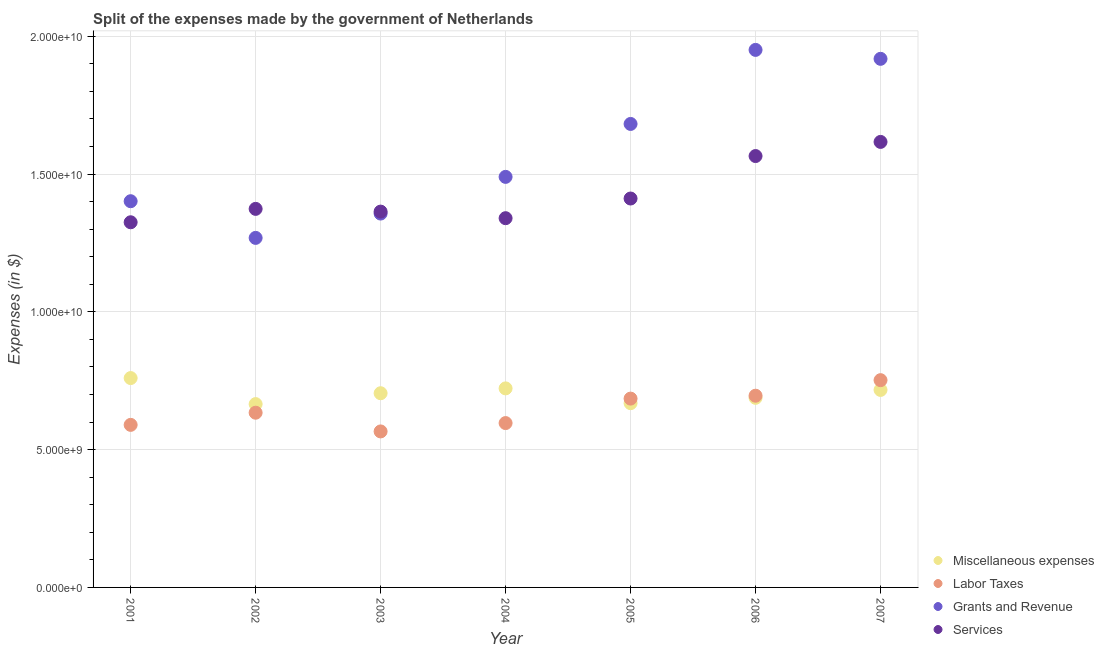How many different coloured dotlines are there?
Ensure brevity in your answer.  4. Is the number of dotlines equal to the number of legend labels?
Make the answer very short. Yes. What is the amount spent on labor taxes in 2002?
Your response must be concise. 6.34e+09. Across all years, what is the maximum amount spent on grants and revenue?
Offer a very short reply. 1.95e+1. Across all years, what is the minimum amount spent on services?
Give a very brief answer. 1.33e+1. In which year was the amount spent on grants and revenue maximum?
Make the answer very short. 2006. What is the total amount spent on labor taxes in the graph?
Ensure brevity in your answer.  4.52e+1. What is the difference between the amount spent on grants and revenue in 2002 and that in 2005?
Make the answer very short. -4.14e+09. What is the difference between the amount spent on miscellaneous expenses in 2003 and the amount spent on labor taxes in 2004?
Ensure brevity in your answer.  1.08e+09. What is the average amount spent on services per year?
Your response must be concise. 1.43e+1. In the year 2002, what is the difference between the amount spent on miscellaneous expenses and amount spent on services?
Keep it short and to the point. -7.08e+09. In how many years, is the amount spent on services greater than 14000000000 $?
Make the answer very short. 3. What is the ratio of the amount spent on grants and revenue in 2002 to that in 2004?
Offer a terse response. 0.85. Is the amount spent on miscellaneous expenses in 2004 less than that in 2007?
Make the answer very short. No. What is the difference between the highest and the second highest amount spent on miscellaneous expenses?
Make the answer very short. 3.74e+08. What is the difference between the highest and the lowest amount spent on miscellaneous expenses?
Your answer should be very brief. 9.44e+08. In how many years, is the amount spent on grants and revenue greater than the average amount spent on grants and revenue taken over all years?
Keep it short and to the point. 3. Is it the case that in every year, the sum of the amount spent on grants and revenue and amount spent on miscellaneous expenses is greater than the sum of amount spent on services and amount spent on labor taxes?
Give a very brief answer. No. Does the amount spent on miscellaneous expenses monotonically increase over the years?
Provide a short and direct response. No. Is the amount spent on grants and revenue strictly greater than the amount spent on services over the years?
Offer a very short reply. No. How many dotlines are there?
Offer a terse response. 4. Does the graph contain grids?
Provide a short and direct response. Yes. Where does the legend appear in the graph?
Your answer should be compact. Bottom right. How many legend labels are there?
Make the answer very short. 4. What is the title of the graph?
Your answer should be very brief. Split of the expenses made by the government of Netherlands. Does "Source data assessment" appear as one of the legend labels in the graph?
Your response must be concise. No. What is the label or title of the X-axis?
Ensure brevity in your answer.  Year. What is the label or title of the Y-axis?
Give a very brief answer. Expenses (in $). What is the Expenses (in $) of Miscellaneous expenses in 2001?
Your answer should be compact. 7.60e+09. What is the Expenses (in $) of Labor Taxes in 2001?
Offer a terse response. 5.90e+09. What is the Expenses (in $) in Grants and Revenue in 2001?
Keep it short and to the point. 1.40e+1. What is the Expenses (in $) in Services in 2001?
Ensure brevity in your answer.  1.33e+1. What is the Expenses (in $) in Miscellaneous expenses in 2002?
Your answer should be very brief. 6.65e+09. What is the Expenses (in $) of Labor Taxes in 2002?
Ensure brevity in your answer.  6.34e+09. What is the Expenses (in $) in Grants and Revenue in 2002?
Offer a very short reply. 1.27e+1. What is the Expenses (in $) in Services in 2002?
Offer a very short reply. 1.37e+1. What is the Expenses (in $) in Miscellaneous expenses in 2003?
Your response must be concise. 7.05e+09. What is the Expenses (in $) in Labor Taxes in 2003?
Keep it short and to the point. 5.66e+09. What is the Expenses (in $) of Grants and Revenue in 2003?
Your answer should be very brief. 1.36e+1. What is the Expenses (in $) of Services in 2003?
Ensure brevity in your answer.  1.36e+1. What is the Expenses (in $) in Miscellaneous expenses in 2004?
Your response must be concise. 7.22e+09. What is the Expenses (in $) of Labor Taxes in 2004?
Ensure brevity in your answer.  5.96e+09. What is the Expenses (in $) of Grants and Revenue in 2004?
Offer a very short reply. 1.49e+1. What is the Expenses (in $) of Services in 2004?
Your answer should be compact. 1.34e+1. What is the Expenses (in $) in Miscellaneous expenses in 2005?
Your response must be concise. 6.69e+09. What is the Expenses (in $) in Labor Taxes in 2005?
Your response must be concise. 6.85e+09. What is the Expenses (in $) of Grants and Revenue in 2005?
Your answer should be very brief. 1.68e+1. What is the Expenses (in $) in Services in 2005?
Make the answer very short. 1.41e+1. What is the Expenses (in $) in Miscellaneous expenses in 2006?
Your response must be concise. 6.88e+09. What is the Expenses (in $) in Labor Taxes in 2006?
Offer a terse response. 6.96e+09. What is the Expenses (in $) in Grants and Revenue in 2006?
Provide a succinct answer. 1.95e+1. What is the Expenses (in $) in Services in 2006?
Your answer should be very brief. 1.57e+1. What is the Expenses (in $) of Miscellaneous expenses in 2007?
Your answer should be compact. 7.17e+09. What is the Expenses (in $) of Labor Taxes in 2007?
Make the answer very short. 7.52e+09. What is the Expenses (in $) of Grants and Revenue in 2007?
Keep it short and to the point. 1.92e+1. What is the Expenses (in $) of Services in 2007?
Your answer should be compact. 1.62e+1. Across all years, what is the maximum Expenses (in $) in Miscellaneous expenses?
Provide a short and direct response. 7.60e+09. Across all years, what is the maximum Expenses (in $) in Labor Taxes?
Ensure brevity in your answer.  7.52e+09. Across all years, what is the maximum Expenses (in $) of Grants and Revenue?
Offer a terse response. 1.95e+1. Across all years, what is the maximum Expenses (in $) of Services?
Give a very brief answer. 1.62e+1. Across all years, what is the minimum Expenses (in $) of Miscellaneous expenses?
Offer a very short reply. 6.65e+09. Across all years, what is the minimum Expenses (in $) in Labor Taxes?
Offer a terse response. 5.66e+09. Across all years, what is the minimum Expenses (in $) in Grants and Revenue?
Your response must be concise. 1.27e+1. Across all years, what is the minimum Expenses (in $) of Services?
Provide a short and direct response. 1.33e+1. What is the total Expenses (in $) of Miscellaneous expenses in the graph?
Provide a short and direct response. 4.93e+1. What is the total Expenses (in $) of Labor Taxes in the graph?
Offer a very short reply. 4.52e+1. What is the total Expenses (in $) of Grants and Revenue in the graph?
Make the answer very short. 1.11e+11. What is the total Expenses (in $) of Services in the graph?
Make the answer very short. 1.00e+11. What is the difference between the Expenses (in $) of Miscellaneous expenses in 2001 and that in 2002?
Your answer should be very brief. 9.44e+08. What is the difference between the Expenses (in $) in Labor Taxes in 2001 and that in 2002?
Your answer should be compact. -4.41e+08. What is the difference between the Expenses (in $) in Grants and Revenue in 2001 and that in 2002?
Your response must be concise. 1.33e+09. What is the difference between the Expenses (in $) in Services in 2001 and that in 2002?
Your answer should be very brief. -4.86e+08. What is the difference between the Expenses (in $) of Miscellaneous expenses in 2001 and that in 2003?
Ensure brevity in your answer.  5.50e+08. What is the difference between the Expenses (in $) in Labor Taxes in 2001 and that in 2003?
Offer a very short reply. 2.38e+08. What is the difference between the Expenses (in $) of Grants and Revenue in 2001 and that in 2003?
Offer a very short reply. 4.48e+08. What is the difference between the Expenses (in $) in Services in 2001 and that in 2003?
Make the answer very short. -3.87e+08. What is the difference between the Expenses (in $) of Miscellaneous expenses in 2001 and that in 2004?
Make the answer very short. 3.74e+08. What is the difference between the Expenses (in $) of Labor Taxes in 2001 and that in 2004?
Your answer should be very brief. -6.50e+07. What is the difference between the Expenses (in $) of Grants and Revenue in 2001 and that in 2004?
Your answer should be compact. -8.83e+08. What is the difference between the Expenses (in $) in Services in 2001 and that in 2004?
Offer a very short reply. -1.48e+08. What is the difference between the Expenses (in $) in Miscellaneous expenses in 2001 and that in 2005?
Provide a succinct answer. 9.11e+08. What is the difference between the Expenses (in $) of Labor Taxes in 2001 and that in 2005?
Provide a succinct answer. -9.53e+08. What is the difference between the Expenses (in $) in Grants and Revenue in 2001 and that in 2005?
Your response must be concise. -2.80e+09. What is the difference between the Expenses (in $) in Services in 2001 and that in 2005?
Offer a very short reply. -8.62e+08. What is the difference between the Expenses (in $) of Miscellaneous expenses in 2001 and that in 2006?
Make the answer very short. 7.17e+08. What is the difference between the Expenses (in $) in Labor Taxes in 2001 and that in 2006?
Your answer should be very brief. -1.06e+09. What is the difference between the Expenses (in $) of Grants and Revenue in 2001 and that in 2006?
Make the answer very short. -5.49e+09. What is the difference between the Expenses (in $) in Services in 2001 and that in 2006?
Offer a terse response. -2.40e+09. What is the difference between the Expenses (in $) in Miscellaneous expenses in 2001 and that in 2007?
Provide a short and direct response. 4.30e+08. What is the difference between the Expenses (in $) in Labor Taxes in 2001 and that in 2007?
Provide a short and direct response. -1.62e+09. What is the difference between the Expenses (in $) in Grants and Revenue in 2001 and that in 2007?
Your answer should be very brief. -5.17e+09. What is the difference between the Expenses (in $) in Services in 2001 and that in 2007?
Provide a short and direct response. -2.92e+09. What is the difference between the Expenses (in $) of Miscellaneous expenses in 2002 and that in 2003?
Provide a short and direct response. -3.94e+08. What is the difference between the Expenses (in $) in Labor Taxes in 2002 and that in 2003?
Your answer should be very brief. 6.79e+08. What is the difference between the Expenses (in $) in Grants and Revenue in 2002 and that in 2003?
Your answer should be very brief. -8.83e+08. What is the difference between the Expenses (in $) in Services in 2002 and that in 2003?
Offer a terse response. 9.90e+07. What is the difference between the Expenses (in $) of Miscellaneous expenses in 2002 and that in 2004?
Ensure brevity in your answer.  -5.70e+08. What is the difference between the Expenses (in $) of Labor Taxes in 2002 and that in 2004?
Provide a succinct answer. 3.76e+08. What is the difference between the Expenses (in $) in Grants and Revenue in 2002 and that in 2004?
Provide a short and direct response. -2.21e+09. What is the difference between the Expenses (in $) of Services in 2002 and that in 2004?
Keep it short and to the point. 3.38e+08. What is the difference between the Expenses (in $) of Miscellaneous expenses in 2002 and that in 2005?
Provide a short and direct response. -3.30e+07. What is the difference between the Expenses (in $) in Labor Taxes in 2002 and that in 2005?
Make the answer very short. -5.12e+08. What is the difference between the Expenses (in $) of Grants and Revenue in 2002 and that in 2005?
Provide a short and direct response. -4.14e+09. What is the difference between the Expenses (in $) in Services in 2002 and that in 2005?
Ensure brevity in your answer.  -3.76e+08. What is the difference between the Expenses (in $) in Miscellaneous expenses in 2002 and that in 2006?
Make the answer very short. -2.27e+08. What is the difference between the Expenses (in $) in Labor Taxes in 2002 and that in 2006?
Your answer should be very brief. -6.17e+08. What is the difference between the Expenses (in $) in Grants and Revenue in 2002 and that in 2006?
Provide a succinct answer. -6.82e+09. What is the difference between the Expenses (in $) of Services in 2002 and that in 2006?
Make the answer very short. -1.92e+09. What is the difference between the Expenses (in $) in Miscellaneous expenses in 2002 and that in 2007?
Give a very brief answer. -5.14e+08. What is the difference between the Expenses (in $) in Labor Taxes in 2002 and that in 2007?
Offer a very short reply. -1.18e+09. What is the difference between the Expenses (in $) in Grants and Revenue in 2002 and that in 2007?
Offer a very short reply. -6.50e+09. What is the difference between the Expenses (in $) in Services in 2002 and that in 2007?
Give a very brief answer. -2.43e+09. What is the difference between the Expenses (in $) in Miscellaneous expenses in 2003 and that in 2004?
Your answer should be very brief. -1.76e+08. What is the difference between the Expenses (in $) in Labor Taxes in 2003 and that in 2004?
Provide a succinct answer. -3.03e+08. What is the difference between the Expenses (in $) of Grants and Revenue in 2003 and that in 2004?
Keep it short and to the point. -1.33e+09. What is the difference between the Expenses (in $) in Services in 2003 and that in 2004?
Ensure brevity in your answer.  2.39e+08. What is the difference between the Expenses (in $) of Miscellaneous expenses in 2003 and that in 2005?
Offer a very short reply. 3.61e+08. What is the difference between the Expenses (in $) of Labor Taxes in 2003 and that in 2005?
Your response must be concise. -1.19e+09. What is the difference between the Expenses (in $) in Grants and Revenue in 2003 and that in 2005?
Offer a very short reply. -3.25e+09. What is the difference between the Expenses (in $) of Services in 2003 and that in 2005?
Keep it short and to the point. -4.75e+08. What is the difference between the Expenses (in $) of Miscellaneous expenses in 2003 and that in 2006?
Provide a short and direct response. 1.67e+08. What is the difference between the Expenses (in $) of Labor Taxes in 2003 and that in 2006?
Give a very brief answer. -1.30e+09. What is the difference between the Expenses (in $) in Grants and Revenue in 2003 and that in 2006?
Your response must be concise. -5.94e+09. What is the difference between the Expenses (in $) in Services in 2003 and that in 2006?
Your response must be concise. -2.02e+09. What is the difference between the Expenses (in $) in Miscellaneous expenses in 2003 and that in 2007?
Offer a terse response. -1.20e+08. What is the difference between the Expenses (in $) of Labor Taxes in 2003 and that in 2007?
Your response must be concise. -1.86e+09. What is the difference between the Expenses (in $) in Grants and Revenue in 2003 and that in 2007?
Keep it short and to the point. -5.62e+09. What is the difference between the Expenses (in $) in Services in 2003 and that in 2007?
Provide a short and direct response. -2.53e+09. What is the difference between the Expenses (in $) of Miscellaneous expenses in 2004 and that in 2005?
Offer a very short reply. 5.37e+08. What is the difference between the Expenses (in $) of Labor Taxes in 2004 and that in 2005?
Make the answer very short. -8.88e+08. What is the difference between the Expenses (in $) in Grants and Revenue in 2004 and that in 2005?
Ensure brevity in your answer.  -1.92e+09. What is the difference between the Expenses (in $) of Services in 2004 and that in 2005?
Your answer should be very brief. -7.14e+08. What is the difference between the Expenses (in $) of Miscellaneous expenses in 2004 and that in 2006?
Offer a terse response. 3.43e+08. What is the difference between the Expenses (in $) of Labor Taxes in 2004 and that in 2006?
Give a very brief answer. -9.93e+08. What is the difference between the Expenses (in $) of Grants and Revenue in 2004 and that in 2006?
Provide a short and direct response. -4.61e+09. What is the difference between the Expenses (in $) of Services in 2004 and that in 2006?
Offer a very short reply. -2.26e+09. What is the difference between the Expenses (in $) in Miscellaneous expenses in 2004 and that in 2007?
Make the answer very short. 5.60e+07. What is the difference between the Expenses (in $) of Labor Taxes in 2004 and that in 2007?
Your answer should be very brief. -1.56e+09. What is the difference between the Expenses (in $) of Grants and Revenue in 2004 and that in 2007?
Offer a very short reply. -4.28e+09. What is the difference between the Expenses (in $) in Services in 2004 and that in 2007?
Ensure brevity in your answer.  -2.77e+09. What is the difference between the Expenses (in $) of Miscellaneous expenses in 2005 and that in 2006?
Provide a short and direct response. -1.94e+08. What is the difference between the Expenses (in $) of Labor Taxes in 2005 and that in 2006?
Provide a succinct answer. -1.05e+08. What is the difference between the Expenses (in $) in Grants and Revenue in 2005 and that in 2006?
Your answer should be very brief. -2.69e+09. What is the difference between the Expenses (in $) in Services in 2005 and that in 2006?
Keep it short and to the point. -1.54e+09. What is the difference between the Expenses (in $) in Miscellaneous expenses in 2005 and that in 2007?
Keep it short and to the point. -4.81e+08. What is the difference between the Expenses (in $) in Labor Taxes in 2005 and that in 2007?
Make the answer very short. -6.69e+08. What is the difference between the Expenses (in $) of Grants and Revenue in 2005 and that in 2007?
Provide a short and direct response. -2.36e+09. What is the difference between the Expenses (in $) of Services in 2005 and that in 2007?
Ensure brevity in your answer.  -2.05e+09. What is the difference between the Expenses (in $) of Miscellaneous expenses in 2006 and that in 2007?
Ensure brevity in your answer.  -2.87e+08. What is the difference between the Expenses (in $) in Labor Taxes in 2006 and that in 2007?
Ensure brevity in your answer.  -5.64e+08. What is the difference between the Expenses (in $) of Grants and Revenue in 2006 and that in 2007?
Provide a short and direct response. 3.24e+08. What is the difference between the Expenses (in $) in Services in 2006 and that in 2007?
Make the answer very short. -5.13e+08. What is the difference between the Expenses (in $) in Miscellaneous expenses in 2001 and the Expenses (in $) in Labor Taxes in 2002?
Make the answer very short. 1.26e+09. What is the difference between the Expenses (in $) in Miscellaneous expenses in 2001 and the Expenses (in $) in Grants and Revenue in 2002?
Your answer should be compact. -5.09e+09. What is the difference between the Expenses (in $) in Miscellaneous expenses in 2001 and the Expenses (in $) in Services in 2002?
Give a very brief answer. -6.14e+09. What is the difference between the Expenses (in $) in Labor Taxes in 2001 and the Expenses (in $) in Grants and Revenue in 2002?
Your response must be concise. -6.78e+09. What is the difference between the Expenses (in $) of Labor Taxes in 2001 and the Expenses (in $) of Services in 2002?
Offer a very short reply. -7.84e+09. What is the difference between the Expenses (in $) in Grants and Revenue in 2001 and the Expenses (in $) in Services in 2002?
Provide a short and direct response. 2.78e+08. What is the difference between the Expenses (in $) in Miscellaneous expenses in 2001 and the Expenses (in $) in Labor Taxes in 2003?
Provide a short and direct response. 1.94e+09. What is the difference between the Expenses (in $) of Miscellaneous expenses in 2001 and the Expenses (in $) of Grants and Revenue in 2003?
Provide a short and direct response. -5.97e+09. What is the difference between the Expenses (in $) in Miscellaneous expenses in 2001 and the Expenses (in $) in Services in 2003?
Offer a terse response. -6.04e+09. What is the difference between the Expenses (in $) in Labor Taxes in 2001 and the Expenses (in $) in Grants and Revenue in 2003?
Your answer should be compact. -7.67e+09. What is the difference between the Expenses (in $) of Labor Taxes in 2001 and the Expenses (in $) of Services in 2003?
Ensure brevity in your answer.  -7.74e+09. What is the difference between the Expenses (in $) of Grants and Revenue in 2001 and the Expenses (in $) of Services in 2003?
Your answer should be very brief. 3.77e+08. What is the difference between the Expenses (in $) in Miscellaneous expenses in 2001 and the Expenses (in $) in Labor Taxes in 2004?
Offer a terse response. 1.63e+09. What is the difference between the Expenses (in $) in Miscellaneous expenses in 2001 and the Expenses (in $) in Grants and Revenue in 2004?
Your answer should be compact. -7.30e+09. What is the difference between the Expenses (in $) in Miscellaneous expenses in 2001 and the Expenses (in $) in Services in 2004?
Keep it short and to the point. -5.80e+09. What is the difference between the Expenses (in $) in Labor Taxes in 2001 and the Expenses (in $) in Grants and Revenue in 2004?
Offer a very short reply. -9.00e+09. What is the difference between the Expenses (in $) in Labor Taxes in 2001 and the Expenses (in $) in Services in 2004?
Your answer should be compact. -7.50e+09. What is the difference between the Expenses (in $) of Grants and Revenue in 2001 and the Expenses (in $) of Services in 2004?
Provide a short and direct response. 6.16e+08. What is the difference between the Expenses (in $) in Miscellaneous expenses in 2001 and the Expenses (in $) in Labor Taxes in 2005?
Offer a terse response. 7.45e+08. What is the difference between the Expenses (in $) in Miscellaneous expenses in 2001 and the Expenses (in $) in Grants and Revenue in 2005?
Ensure brevity in your answer.  -9.22e+09. What is the difference between the Expenses (in $) in Miscellaneous expenses in 2001 and the Expenses (in $) in Services in 2005?
Make the answer very short. -6.52e+09. What is the difference between the Expenses (in $) in Labor Taxes in 2001 and the Expenses (in $) in Grants and Revenue in 2005?
Your answer should be compact. -1.09e+1. What is the difference between the Expenses (in $) of Labor Taxes in 2001 and the Expenses (in $) of Services in 2005?
Give a very brief answer. -8.21e+09. What is the difference between the Expenses (in $) in Grants and Revenue in 2001 and the Expenses (in $) in Services in 2005?
Offer a very short reply. -9.80e+07. What is the difference between the Expenses (in $) in Miscellaneous expenses in 2001 and the Expenses (in $) in Labor Taxes in 2006?
Your answer should be compact. 6.40e+08. What is the difference between the Expenses (in $) of Miscellaneous expenses in 2001 and the Expenses (in $) of Grants and Revenue in 2006?
Ensure brevity in your answer.  -1.19e+1. What is the difference between the Expenses (in $) of Miscellaneous expenses in 2001 and the Expenses (in $) of Services in 2006?
Give a very brief answer. -8.06e+09. What is the difference between the Expenses (in $) of Labor Taxes in 2001 and the Expenses (in $) of Grants and Revenue in 2006?
Give a very brief answer. -1.36e+1. What is the difference between the Expenses (in $) of Labor Taxes in 2001 and the Expenses (in $) of Services in 2006?
Give a very brief answer. -9.76e+09. What is the difference between the Expenses (in $) in Grants and Revenue in 2001 and the Expenses (in $) in Services in 2006?
Keep it short and to the point. -1.64e+09. What is the difference between the Expenses (in $) in Miscellaneous expenses in 2001 and the Expenses (in $) in Labor Taxes in 2007?
Offer a terse response. 7.60e+07. What is the difference between the Expenses (in $) in Miscellaneous expenses in 2001 and the Expenses (in $) in Grants and Revenue in 2007?
Provide a succinct answer. -1.16e+1. What is the difference between the Expenses (in $) in Miscellaneous expenses in 2001 and the Expenses (in $) in Services in 2007?
Ensure brevity in your answer.  -8.57e+09. What is the difference between the Expenses (in $) in Labor Taxes in 2001 and the Expenses (in $) in Grants and Revenue in 2007?
Your response must be concise. -1.33e+1. What is the difference between the Expenses (in $) in Labor Taxes in 2001 and the Expenses (in $) in Services in 2007?
Your response must be concise. -1.03e+1. What is the difference between the Expenses (in $) of Grants and Revenue in 2001 and the Expenses (in $) of Services in 2007?
Make the answer very short. -2.15e+09. What is the difference between the Expenses (in $) in Miscellaneous expenses in 2002 and the Expenses (in $) in Labor Taxes in 2003?
Offer a very short reply. 9.92e+08. What is the difference between the Expenses (in $) of Miscellaneous expenses in 2002 and the Expenses (in $) of Grants and Revenue in 2003?
Offer a very short reply. -6.91e+09. What is the difference between the Expenses (in $) of Miscellaneous expenses in 2002 and the Expenses (in $) of Services in 2003?
Provide a short and direct response. -6.98e+09. What is the difference between the Expenses (in $) in Labor Taxes in 2002 and the Expenses (in $) in Grants and Revenue in 2003?
Provide a short and direct response. -7.23e+09. What is the difference between the Expenses (in $) in Labor Taxes in 2002 and the Expenses (in $) in Services in 2003?
Offer a terse response. -7.30e+09. What is the difference between the Expenses (in $) of Grants and Revenue in 2002 and the Expenses (in $) of Services in 2003?
Offer a terse response. -9.54e+08. What is the difference between the Expenses (in $) of Miscellaneous expenses in 2002 and the Expenses (in $) of Labor Taxes in 2004?
Your answer should be compact. 6.89e+08. What is the difference between the Expenses (in $) in Miscellaneous expenses in 2002 and the Expenses (in $) in Grants and Revenue in 2004?
Your answer should be very brief. -8.24e+09. What is the difference between the Expenses (in $) of Miscellaneous expenses in 2002 and the Expenses (in $) of Services in 2004?
Give a very brief answer. -6.75e+09. What is the difference between the Expenses (in $) in Labor Taxes in 2002 and the Expenses (in $) in Grants and Revenue in 2004?
Keep it short and to the point. -8.56e+09. What is the difference between the Expenses (in $) of Labor Taxes in 2002 and the Expenses (in $) of Services in 2004?
Give a very brief answer. -7.06e+09. What is the difference between the Expenses (in $) of Grants and Revenue in 2002 and the Expenses (in $) of Services in 2004?
Offer a terse response. -7.15e+08. What is the difference between the Expenses (in $) of Miscellaneous expenses in 2002 and the Expenses (in $) of Labor Taxes in 2005?
Make the answer very short. -1.99e+08. What is the difference between the Expenses (in $) of Miscellaneous expenses in 2002 and the Expenses (in $) of Grants and Revenue in 2005?
Give a very brief answer. -1.02e+1. What is the difference between the Expenses (in $) of Miscellaneous expenses in 2002 and the Expenses (in $) of Services in 2005?
Offer a very short reply. -7.46e+09. What is the difference between the Expenses (in $) of Labor Taxes in 2002 and the Expenses (in $) of Grants and Revenue in 2005?
Your answer should be compact. -1.05e+1. What is the difference between the Expenses (in $) in Labor Taxes in 2002 and the Expenses (in $) in Services in 2005?
Offer a terse response. -7.77e+09. What is the difference between the Expenses (in $) of Grants and Revenue in 2002 and the Expenses (in $) of Services in 2005?
Your answer should be compact. -1.43e+09. What is the difference between the Expenses (in $) in Miscellaneous expenses in 2002 and the Expenses (in $) in Labor Taxes in 2006?
Ensure brevity in your answer.  -3.04e+08. What is the difference between the Expenses (in $) in Miscellaneous expenses in 2002 and the Expenses (in $) in Grants and Revenue in 2006?
Your answer should be compact. -1.29e+1. What is the difference between the Expenses (in $) of Miscellaneous expenses in 2002 and the Expenses (in $) of Services in 2006?
Give a very brief answer. -9.00e+09. What is the difference between the Expenses (in $) in Labor Taxes in 2002 and the Expenses (in $) in Grants and Revenue in 2006?
Make the answer very short. -1.32e+1. What is the difference between the Expenses (in $) in Labor Taxes in 2002 and the Expenses (in $) in Services in 2006?
Keep it short and to the point. -9.31e+09. What is the difference between the Expenses (in $) of Grants and Revenue in 2002 and the Expenses (in $) of Services in 2006?
Your response must be concise. -2.97e+09. What is the difference between the Expenses (in $) of Miscellaneous expenses in 2002 and the Expenses (in $) of Labor Taxes in 2007?
Provide a succinct answer. -8.68e+08. What is the difference between the Expenses (in $) of Miscellaneous expenses in 2002 and the Expenses (in $) of Grants and Revenue in 2007?
Offer a terse response. -1.25e+1. What is the difference between the Expenses (in $) in Miscellaneous expenses in 2002 and the Expenses (in $) in Services in 2007?
Provide a succinct answer. -9.51e+09. What is the difference between the Expenses (in $) in Labor Taxes in 2002 and the Expenses (in $) in Grants and Revenue in 2007?
Give a very brief answer. -1.28e+1. What is the difference between the Expenses (in $) in Labor Taxes in 2002 and the Expenses (in $) in Services in 2007?
Ensure brevity in your answer.  -9.83e+09. What is the difference between the Expenses (in $) in Grants and Revenue in 2002 and the Expenses (in $) in Services in 2007?
Provide a succinct answer. -3.48e+09. What is the difference between the Expenses (in $) in Miscellaneous expenses in 2003 and the Expenses (in $) in Labor Taxes in 2004?
Provide a succinct answer. 1.08e+09. What is the difference between the Expenses (in $) in Miscellaneous expenses in 2003 and the Expenses (in $) in Grants and Revenue in 2004?
Your answer should be very brief. -7.85e+09. What is the difference between the Expenses (in $) in Miscellaneous expenses in 2003 and the Expenses (in $) in Services in 2004?
Give a very brief answer. -6.35e+09. What is the difference between the Expenses (in $) of Labor Taxes in 2003 and the Expenses (in $) of Grants and Revenue in 2004?
Keep it short and to the point. -9.24e+09. What is the difference between the Expenses (in $) of Labor Taxes in 2003 and the Expenses (in $) of Services in 2004?
Make the answer very short. -7.74e+09. What is the difference between the Expenses (in $) of Grants and Revenue in 2003 and the Expenses (in $) of Services in 2004?
Offer a very short reply. 1.68e+08. What is the difference between the Expenses (in $) of Miscellaneous expenses in 2003 and the Expenses (in $) of Labor Taxes in 2005?
Give a very brief answer. 1.95e+08. What is the difference between the Expenses (in $) of Miscellaneous expenses in 2003 and the Expenses (in $) of Grants and Revenue in 2005?
Your response must be concise. -9.77e+09. What is the difference between the Expenses (in $) in Miscellaneous expenses in 2003 and the Expenses (in $) in Services in 2005?
Your response must be concise. -7.07e+09. What is the difference between the Expenses (in $) in Labor Taxes in 2003 and the Expenses (in $) in Grants and Revenue in 2005?
Keep it short and to the point. -1.12e+1. What is the difference between the Expenses (in $) in Labor Taxes in 2003 and the Expenses (in $) in Services in 2005?
Keep it short and to the point. -8.45e+09. What is the difference between the Expenses (in $) of Grants and Revenue in 2003 and the Expenses (in $) of Services in 2005?
Offer a very short reply. -5.46e+08. What is the difference between the Expenses (in $) of Miscellaneous expenses in 2003 and the Expenses (in $) of Labor Taxes in 2006?
Your response must be concise. 9.00e+07. What is the difference between the Expenses (in $) in Miscellaneous expenses in 2003 and the Expenses (in $) in Grants and Revenue in 2006?
Provide a succinct answer. -1.25e+1. What is the difference between the Expenses (in $) in Miscellaneous expenses in 2003 and the Expenses (in $) in Services in 2006?
Your response must be concise. -8.61e+09. What is the difference between the Expenses (in $) in Labor Taxes in 2003 and the Expenses (in $) in Grants and Revenue in 2006?
Your answer should be very brief. -1.38e+1. What is the difference between the Expenses (in $) of Labor Taxes in 2003 and the Expenses (in $) of Services in 2006?
Ensure brevity in your answer.  -9.99e+09. What is the difference between the Expenses (in $) of Grants and Revenue in 2003 and the Expenses (in $) of Services in 2006?
Your response must be concise. -2.09e+09. What is the difference between the Expenses (in $) in Miscellaneous expenses in 2003 and the Expenses (in $) in Labor Taxes in 2007?
Offer a very short reply. -4.74e+08. What is the difference between the Expenses (in $) of Miscellaneous expenses in 2003 and the Expenses (in $) of Grants and Revenue in 2007?
Provide a succinct answer. -1.21e+1. What is the difference between the Expenses (in $) of Miscellaneous expenses in 2003 and the Expenses (in $) of Services in 2007?
Provide a short and direct response. -9.12e+09. What is the difference between the Expenses (in $) in Labor Taxes in 2003 and the Expenses (in $) in Grants and Revenue in 2007?
Your answer should be compact. -1.35e+1. What is the difference between the Expenses (in $) of Labor Taxes in 2003 and the Expenses (in $) of Services in 2007?
Make the answer very short. -1.05e+1. What is the difference between the Expenses (in $) of Grants and Revenue in 2003 and the Expenses (in $) of Services in 2007?
Give a very brief answer. -2.60e+09. What is the difference between the Expenses (in $) in Miscellaneous expenses in 2004 and the Expenses (in $) in Labor Taxes in 2005?
Your answer should be compact. 3.71e+08. What is the difference between the Expenses (in $) of Miscellaneous expenses in 2004 and the Expenses (in $) of Grants and Revenue in 2005?
Offer a terse response. -9.60e+09. What is the difference between the Expenses (in $) in Miscellaneous expenses in 2004 and the Expenses (in $) in Services in 2005?
Your answer should be compact. -6.89e+09. What is the difference between the Expenses (in $) in Labor Taxes in 2004 and the Expenses (in $) in Grants and Revenue in 2005?
Your answer should be compact. -1.09e+1. What is the difference between the Expenses (in $) in Labor Taxes in 2004 and the Expenses (in $) in Services in 2005?
Your answer should be compact. -8.15e+09. What is the difference between the Expenses (in $) in Grants and Revenue in 2004 and the Expenses (in $) in Services in 2005?
Provide a short and direct response. 7.85e+08. What is the difference between the Expenses (in $) of Miscellaneous expenses in 2004 and the Expenses (in $) of Labor Taxes in 2006?
Your answer should be very brief. 2.66e+08. What is the difference between the Expenses (in $) in Miscellaneous expenses in 2004 and the Expenses (in $) in Grants and Revenue in 2006?
Make the answer very short. -1.23e+1. What is the difference between the Expenses (in $) in Miscellaneous expenses in 2004 and the Expenses (in $) in Services in 2006?
Provide a short and direct response. -8.43e+09. What is the difference between the Expenses (in $) in Labor Taxes in 2004 and the Expenses (in $) in Grants and Revenue in 2006?
Make the answer very short. -1.35e+1. What is the difference between the Expenses (in $) in Labor Taxes in 2004 and the Expenses (in $) in Services in 2006?
Keep it short and to the point. -9.69e+09. What is the difference between the Expenses (in $) in Grants and Revenue in 2004 and the Expenses (in $) in Services in 2006?
Your answer should be very brief. -7.56e+08. What is the difference between the Expenses (in $) of Miscellaneous expenses in 2004 and the Expenses (in $) of Labor Taxes in 2007?
Keep it short and to the point. -2.98e+08. What is the difference between the Expenses (in $) of Miscellaneous expenses in 2004 and the Expenses (in $) of Grants and Revenue in 2007?
Provide a short and direct response. -1.20e+1. What is the difference between the Expenses (in $) of Miscellaneous expenses in 2004 and the Expenses (in $) of Services in 2007?
Make the answer very short. -8.94e+09. What is the difference between the Expenses (in $) in Labor Taxes in 2004 and the Expenses (in $) in Grants and Revenue in 2007?
Provide a short and direct response. -1.32e+1. What is the difference between the Expenses (in $) in Labor Taxes in 2004 and the Expenses (in $) in Services in 2007?
Offer a very short reply. -1.02e+1. What is the difference between the Expenses (in $) in Grants and Revenue in 2004 and the Expenses (in $) in Services in 2007?
Keep it short and to the point. -1.27e+09. What is the difference between the Expenses (in $) in Miscellaneous expenses in 2005 and the Expenses (in $) in Labor Taxes in 2006?
Provide a succinct answer. -2.71e+08. What is the difference between the Expenses (in $) of Miscellaneous expenses in 2005 and the Expenses (in $) of Grants and Revenue in 2006?
Ensure brevity in your answer.  -1.28e+1. What is the difference between the Expenses (in $) in Miscellaneous expenses in 2005 and the Expenses (in $) in Services in 2006?
Offer a terse response. -8.97e+09. What is the difference between the Expenses (in $) in Labor Taxes in 2005 and the Expenses (in $) in Grants and Revenue in 2006?
Provide a succinct answer. -1.27e+1. What is the difference between the Expenses (in $) in Labor Taxes in 2005 and the Expenses (in $) in Services in 2006?
Your response must be concise. -8.80e+09. What is the difference between the Expenses (in $) in Grants and Revenue in 2005 and the Expenses (in $) in Services in 2006?
Make the answer very short. 1.16e+09. What is the difference between the Expenses (in $) of Miscellaneous expenses in 2005 and the Expenses (in $) of Labor Taxes in 2007?
Provide a short and direct response. -8.35e+08. What is the difference between the Expenses (in $) in Miscellaneous expenses in 2005 and the Expenses (in $) in Grants and Revenue in 2007?
Offer a very short reply. -1.25e+1. What is the difference between the Expenses (in $) of Miscellaneous expenses in 2005 and the Expenses (in $) of Services in 2007?
Make the answer very short. -9.48e+09. What is the difference between the Expenses (in $) in Labor Taxes in 2005 and the Expenses (in $) in Grants and Revenue in 2007?
Offer a terse response. -1.23e+1. What is the difference between the Expenses (in $) in Labor Taxes in 2005 and the Expenses (in $) in Services in 2007?
Keep it short and to the point. -9.32e+09. What is the difference between the Expenses (in $) of Grants and Revenue in 2005 and the Expenses (in $) of Services in 2007?
Offer a terse response. 6.52e+08. What is the difference between the Expenses (in $) of Miscellaneous expenses in 2006 and the Expenses (in $) of Labor Taxes in 2007?
Offer a very short reply. -6.41e+08. What is the difference between the Expenses (in $) in Miscellaneous expenses in 2006 and the Expenses (in $) in Grants and Revenue in 2007?
Your answer should be very brief. -1.23e+1. What is the difference between the Expenses (in $) in Miscellaneous expenses in 2006 and the Expenses (in $) in Services in 2007?
Offer a terse response. -9.29e+09. What is the difference between the Expenses (in $) of Labor Taxes in 2006 and the Expenses (in $) of Grants and Revenue in 2007?
Ensure brevity in your answer.  -1.22e+1. What is the difference between the Expenses (in $) in Labor Taxes in 2006 and the Expenses (in $) in Services in 2007?
Keep it short and to the point. -9.21e+09. What is the difference between the Expenses (in $) in Grants and Revenue in 2006 and the Expenses (in $) in Services in 2007?
Your response must be concise. 3.34e+09. What is the average Expenses (in $) of Miscellaneous expenses per year?
Your answer should be compact. 7.04e+09. What is the average Expenses (in $) of Labor Taxes per year?
Give a very brief answer. 6.46e+09. What is the average Expenses (in $) in Grants and Revenue per year?
Your answer should be compact. 1.58e+1. What is the average Expenses (in $) in Services per year?
Provide a succinct answer. 1.43e+1. In the year 2001, what is the difference between the Expenses (in $) in Miscellaneous expenses and Expenses (in $) in Labor Taxes?
Provide a succinct answer. 1.70e+09. In the year 2001, what is the difference between the Expenses (in $) in Miscellaneous expenses and Expenses (in $) in Grants and Revenue?
Keep it short and to the point. -6.42e+09. In the year 2001, what is the difference between the Expenses (in $) in Miscellaneous expenses and Expenses (in $) in Services?
Give a very brief answer. -5.65e+09. In the year 2001, what is the difference between the Expenses (in $) of Labor Taxes and Expenses (in $) of Grants and Revenue?
Give a very brief answer. -8.12e+09. In the year 2001, what is the difference between the Expenses (in $) in Labor Taxes and Expenses (in $) in Services?
Make the answer very short. -7.35e+09. In the year 2001, what is the difference between the Expenses (in $) in Grants and Revenue and Expenses (in $) in Services?
Offer a terse response. 7.64e+08. In the year 2002, what is the difference between the Expenses (in $) of Miscellaneous expenses and Expenses (in $) of Labor Taxes?
Provide a succinct answer. 3.13e+08. In the year 2002, what is the difference between the Expenses (in $) of Miscellaneous expenses and Expenses (in $) of Grants and Revenue?
Provide a short and direct response. -6.03e+09. In the year 2002, what is the difference between the Expenses (in $) in Miscellaneous expenses and Expenses (in $) in Services?
Offer a terse response. -7.08e+09. In the year 2002, what is the difference between the Expenses (in $) in Labor Taxes and Expenses (in $) in Grants and Revenue?
Your response must be concise. -6.34e+09. In the year 2002, what is the difference between the Expenses (in $) of Labor Taxes and Expenses (in $) of Services?
Provide a short and direct response. -7.40e+09. In the year 2002, what is the difference between the Expenses (in $) of Grants and Revenue and Expenses (in $) of Services?
Keep it short and to the point. -1.05e+09. In the year 2003, what is the difference between the Expenses (in $) of Miscellaneous expenses and Expenses (in $) of Labor Taxes?
Provide a short and direct response. 1.39e+09. In the year 2003, what is the difference between the Expenses (in $) in Miscellaneous expenses and Expenses (in $) in Grants and Revenue?
Provide a short and direct response. -6.52e+09. In the year 2003, what is the difference between the Expenses (in $) of Miscellaneous expenses and Expenses (in $) of Services?
Make the answer very short. -6.59e+09. In the year 2003, what is the difference between the Expenses (in $) in Labor Taxes and Expenses (in $) in Grants and Revenue?
Offer a terse response. -7.91e+09. In the year 2003, what is the difference between the Expenses (in $) in Labor Taxes and Expenses (in $) in Services?
Provide a succinct answer. -7.98e+09. In the year 2003, what is the difference between the Expenses (in $) in Grants and Revenue and Expenses (in $) in Services?
Your answer should be compact. -7.10e+07. In the year 2004, what is the difference between the Expenses (in $) of Miscellaneous expenses and Expenses (in $) of Labor Taxes?
Give a very brief answer. 1.26e+09. In the year 2004, what is the difference between the Expenses (in $) of Miscellaneous expenses and Expenses (in $) of Grants and Revenue?
Keep it short and to the point. -7.68e+09. In the year 2004, what is the difference between the Expenses (in $) of Miscellaneous expenses and Expenses (in $) of Services?
Your answer should be compact. -6.18e+09. In the year 2004, what is the difference between the Expenses (in $) of Labor Taxes and Expenses (in $) of Grants and Revenue?
Give a very brief answer. -8.93e+09. In the year 2004, what is the difference between the Expenses (in $) of Labor Taxes and Expenses (in $) of Services?
Your response must be concise. -7.44e+09. In the year 2004, what is the difference between the Expenses (in $) of Grants and Revenue and Expenses (in $) of Services?
Offer a very short reply. 1.50e+09. In the year 2005, what is the difference between the Expenses (in $) of Miscellaneous expenses and Expenses (in $) of Labor Taxes?
Your answer should be compact. -1.66e+08. In the year 2005, what is the difference between the Expenses (in $) of Miscellaneous expenses and Expenses (in $) of Grants and Revenue?
Provide a succinct answer. -1.01e+1. In the year 2005, what is the difference between the Expenses (in $) of Miscellaneous expenses and Expenses (in $) of Services?
Provide a short and direct response. -7.43e+09. In the year 2005, what is the difference between the Expenses (in $) of Labor Taxes and Expenses (in $) of Grants and Revenue?
Your response must be concise. -9.97e+09. In the year 2005, what is the difference between the Expenses (in $) of Labor Taxes and Expenses (in $) of Services?
Your response must be concise. -7.26e+09. In the year 2005, what is the difference between the Expenses (in $) of Grants and Revenue and Expenses (in $) of Services?
Your answer should be very brief. 2.71e+09. In the year 2006, what is the difference between the Expenses (in $) of Miscellaneous expenses and Expenses (in $) of Labor Taxes?
Make the answer very short. -7.70e+07. In the year 2006, what is the difference between the Expenses (in $) in Miscellaneous expenses and Expenses (in $) in Grants and Revenue?
Provide a short and direct response. -1.26e+1. In the year 2006, what is the difference between the Expenses (in $) in Miscellaneous expenses and Expenses (in $) in Services?
Offer a very short reply. -8.77e+09. In the year 2006, what is the difference between the Expenses (in $) in Labor Taxes and Expenses (in $) in Grants and Revenue?
Keep it short and to the point. -1.25e+1. In the year 2006, what is the difference between the Expenses (in $) in Labor Taxes and Expenses (in $) in Services?
Ensure brevity in your answer.  -8.70e+09. In the year 2006, what is the difference between the Expenses (in $) in Grants and Revenue and Expenses (in $) in Services?
Provide a short and direct response. 3.85e+09. In the year 2007, what is the difference between the Expenses (in $) of Miscellaneous expenses and Expenses (in $) of Labor Taxes?
Offer a very short reply. -3.54e+08. In the year 2007, what is the difference between the Expenses (in $) of Miscellaneous expenses and Expenses (in $) of Grants and Revenue?
Offer a very short reply. -1.20e+1. In the year 2007, what is the difference between the Expenses (in $) in Miscellaneous expenses and Expenses (in $) in Services?
Give a very brief answer. -9.00e+09. In the year 2007, what is the difference between the Expenses (in $) in Labor Taxes and Expenses (in $) in Grants and Revenue?
Give a very brief answer. -1.17e+1. In the year 2007, what is the difference between the Expenses (in $) in Labor Taxes and Expenses (in $) in Services?
Your response must be concise. -8.65e+09. In the year 2007, what is the difference between the Expenses (in $) of Grants and Revenue and Expenses (in $) of Services?
Your answer should be compact. 3.02e+09. What is the ratio of the Expenses (in $) in Miscellaneous expenses in 2001 to that in 2002?
Make the answer very short. 1.14. What is the ratio of the Expenses (in $) in Labor Taxes in 2001 to that in 2002?
Offer a terse response. 0.93. What is the ratio of the Expenses (in $) of Grants and Revenue in 2001 to that in 2002?
Offer a terse response. 1.1. What is the ratio of the Expenses (in $) of Services in 2001 to that in 2002?
Provide a short and direct response. 0.96. What is the ratio of the Expenses (in $) of Miscellaneous expenses in 2001 to that in 2003?
Your answer should be compact. 1.08. What is the ratio of the Expenses (in $) of Labor Taxes in 2001 to that in 2003?
Ensure brevity in your answer.  1.04. What is the ratio of the Expenses (in $) of Grants and Revenue in 2001 to that in 2003?
Ensure brevity in your answer.  1.03. What is the ratio of the Expenses (in $) of Services in 2001 to that in 2003?
Offer a terse response. 0.97. What is the ratio of the Expenses (in $) in Miscellaneous expenses in 2001 to that in 2004?
Your answer should be very brief. 1.05. What is the ratio of the Expenses (in $) in Grants and Revenue in 2001 to that in 2004?
Provide a short and direct response. 0.94. What is the ratio of the Expenses (in $) in Miscellaneous expenses in 2001 to that in 2005?
Your response must be concise. 1.14. What is the ratio of the Expenses (in $) in Labor Taxes in 2001 to that in 2005?
Make the answer very short. 0.86. What is the ratio of the Expenses (in $) of Grants and Revenue in 2001 to that in 2005?
Keep it short and to the point. 0.83. What is the ratio of the Expenses (in $) of Services in 2001 to that in 2005?
Your answer should be very brief. 0.94. What is the ratio of the Expenses (in $) in Miscellaneous expenses in 2001 to that in 2006?
Ensure brevity in your answer.  1.1. What is the ratio of the Expenses (in $) of Labor Taxes in 2001 to that in 2006?
Offer a very short reply. 0.85. What is the ratio of the Expenses (in $) in Grants and Revenue in 2001 to that in 2006?
Offer a very short reply. 0.72. What is the ratio of the Expenses (in $) in Services in 2001 to that in 2006?
Give a very brief answer. 0.85. What is the ratio of the Expenses (in $) of Miscellaneous expenses in 2001 to that in 2007?
Provide a short and direct response. 1.06. What is the ratio of the Expenses (in $) of Labor Taxes in 2001 to that in 2007?
Your answer should be very brief. 0.78. What is the ratio of the Expenses (in $) in Grants and Revenue in 2001 to that in 2007?
Offer a terse response. 0.73. What is the ratio of the Expenses (in $) of Services in 2001 to that in 2007?
Your answer should be compact. 0.82. What is the ratio of the Expenses (in $) of Miscellaneous expenses in 2002 to that in 2003?
Provide a succinct answer. 0.94. What is the ratio of the Expenses (in $) of Labor Taxes in 2002 to that in 2003?
Give a very brief answer. 1.12. What is the ratio of the Expenses (in $) of Grants and Revenue in 2002 to that in 2003?
Give a very brief answer. 0.93. What is the ratio of the Expenses (in $) in Services in 2002 to that in 2003?
Give a very brief answer. 1.01. What is the ratio of the Expenses (in $) of Miscellaneous expenses in 2002 to that in 2004?
Your answer should be very brief. 0.92. What is the ratio of the Expenses (in $) of Labor Taxes in 2002 to that in 2004?
Give a very brief answer. 1.06. What is the ratio of the Expenses (in $) of Grants and Revenue in 2002 to that in 2004?
Give a very brief answer. 0.85. What is the ratio of the Expenses (in $) of Services in 2002 to that in 2004?
Provide a short and direct response. 1.03. What is the ratio of the Expenses (in $) of Labor Taxes in 2002 to that in 2005?
Make the answer very short. 0.93. What is the ratio of the Expenses (in $) in Grants and Revenue in 2002 to that in 2005?
Provide a succinct answer. 0.75. What is the ratio of the Expenses (in $) in Services in 2002 to that in 2005?
Give a very brief answer. 0.97. What is the ratio of the Expenses (in $) in Labor Taxes in 2002 to that in 2006?
Offer a very short reply. 0.91. What is the ratio of the Expenses (in $) in Grants and Revenue in 2002 to that in 2006?
Your answer should be very brief. 0.65. What is the ratio of the Expenses (in $) in Services in 2002 to that in 2006?
Keep it short and to the point. 0.88. What is the ratio of the Expenses (in $) of Miscellaneous expenses in 2002 to that in 2007?
Keep it short and to the point. 0.93. What is the ratio of the Expenses (in $) in Labor Taxes in 2002 to that in 2007?
Provide a succinct answer. 0.84. What is the ratio of the Expenses (in $) of Grants and Revenue in 2002 to that in 2007?
Provide a short and direct response. 0.66. What is the ratio of the Expenses (in $) in Services in 2002 to that in 2007?
Your answer should be very brief. 0.85. What is the ratio of the Expenses (in $) of Miscellaneous expenses in 2003 to that in 2004?
Make the answer very short. 0.98. What is the ratio of the Expenses (in $) in Labor Taxes in 2003 to that in 2004?
Ensure brevity in your answer.  0.95. What is the ratio of the Expenses (in $) of Grants and Revenue in 2003 to that in 2004?
Your response must be concise. 0.91. What is the ratio of the Expenses (in $) in Services in 2003 to that in 2004?
Your answer should be very brief. 1.02. What is the ratio of the Expenses (in $) in Miscellaneous expenses in 2003 to that in 2005?
Your response must be concise. 1.05. What is the ratio of the Expenses (in $) of Labor Taxes in 2003 to that in 2005?
Ensure brevity in your answer.  0.83. What is the ratio of the Expenses (in $) of Grants and Revenue in 2003 to that in 2005?
Your response must be concise. 0.81. What is the ratio of the Expenses (in $) of Services in 2003 to that in 2005?
Offer a very short reply. 0.97. What is the ratio of the Expenses (in $) in Miscellaneous expenses in 2003 to that in 2006?
Make the answer very short. 1.02. What is the ratio of the Expenses (in $) of Labor Taxes in 2003 to that in 2006?
Make the answer very short. 0.81. What is the ratio of the Expenses (in $) of Grants and Revenue in 2003 to that in 2006?
Your answer should be very brief. 0.7. What is the ratio of the Expenses (in $) in Services in 2003 to that in 2006?
Your answer should be very brief. 0.87. What is the ratio of the Expenses (in $) in Miscellaneous expenses in 2003 to that in 2007?
Your response must be concise. 0.98. What is the ratio of the Expenses (in $) of Labor Taxes in 2003 to that in 2007?
Your answer should be compact. 0.75. What is the ratio of the Expenses (in $) of Grants and Revenue in 2003 to that in 2007?
Your response must be concise. 0.71. What is the ratio of the Expenses (in $) of Services in 2003 to that in 2007?
Offer a terse response. 0.84. What is the ratio of the Expenses (in $) of Miscellaneous expenses in 2004 to that in 2005?
Your response must be concise. 1.08. What is the ratio of the Expenses (in $) of Labor Taxes in 2004 to that in 2005?
Make the answer very short. 0.87. What is the ratio of the Expenses (in $) in Grants and Revenue in 2004 to that in 2005?
Ensure brevity in your answer.  0.89. What is the ratio of the Expenses (in $) of Services in 2004 to that in 2005?
Keep it short and to the point. 0.95. What is the ratio of the Expenses (in $) of Miscellaneous expenses in 2004 to that in 2006?
Make the answer very short. 1.05. What is the ratio of the Expenses (in $) in Labor Taxes in 2004 to that in 2006?
Offer a very short reply. 0.86. What is the ratio of the Expenses (in $) in Grants and Revenue in 2004 to that in 2006?
Your answer should be very brief. 0.76. What is the ratio of the Expenses (in $) in Services in 2004 to that in 2006?
Your answer should be compact. 0.86. What is the ratio of the Expenses (in $) of Labor Taxes in 2004 to that in 2007?
Ensure brevity in your answer.  0.79. What is the ratio of the Expenses (in $) in Grants and Revenue in 2004 to that in 2007?
Your answer should be very brief. 0.78. What is the ratio of the Expenses (in $) of Services in 2004 to that in 2007?
Provide a succinct answer. 0.83. What is the ratio of the Expenses (in $) in Miscellaneous expenses in 2005 to that in 2006?
Provide a short and direct response. 0.97. What is the ratio of the Expenses (in $) of Labor Taxes in 2005 to that in 2006?
Offer a terse response. 0.98. What is the ratio of the Expenses (in $) of Grants and Revenue in 2005 to that in 2006?
Provide a short and direct response. 0.86. What is the ratio of the Expenses (in $) of Services in 2005 to that in 2006?
Keep it short and to the point. 0.9. What is the ratio of the Expenses (in $) in Miscellaneous expenses in 2005 to that in 2007?
Your answer should be very brief. 0.93. What is the ratio of the Expenses (in $) in Labor Taxes in 2005 to that in 2007?
Keep it short and to the point. 0.91. What is the ratio of the Expenses (in $) of Grants and Revenue in 2005 to that in 2007?
Keep it short and to the point. 0.88. What is the ratio of the Expenses (in $) in Services in 2005 to that in 2007?
Ensure brevity in your answer.  0.87. What is the ratio of the Expenses (in $) in Labor Taxes in 2006 to that in 2007?
Give a very brief answer. 0.93. What is the ratio of the Expenses (in $) of Grants and Revenue in 2006 to that in 2007?
Give a very brief answer. 1.02. What is the ratio of the Expenses (in $) in Services in 2006 to that in 2007?
Ensure brevity in your answer.  0.97. What is the difference between the highest and the second highest Expenses (in $) in Miscellaneous expenses?
Ensure brevity in your answer.  3.74e+08. What is the difference between the highest and the second highest Expenses (in $) of Labor Taxes?
Provide a succinct answer. 5.64e+08. What is the difference between the highest and the second highest Expenses (in $) of Grants and Revenue?
Your response must be concise. 3.24e+08. What is the difference between the highest and the second highest Expenses (in $) in Services?
Keep it short and to the point. 5.13e+08. What is the difference between the highest and the lowest Expenses (in $) in Miscellaneous expenses?
Give a very brief answer. 9.44e+08. What is the difference between the highest and the lowest Expenses (in $) of Labor Taxes?
Keep it short and to the point. 1.86e+09. What is the difference between the highest and the lowest Expenses (in $) of Grants and Revenue?
Offer a very short reply. 6.82e+09. What is the difference between the highest and the lowest Expenses (in $) in Services?
Give a very brief answer. 2.92e+09. 